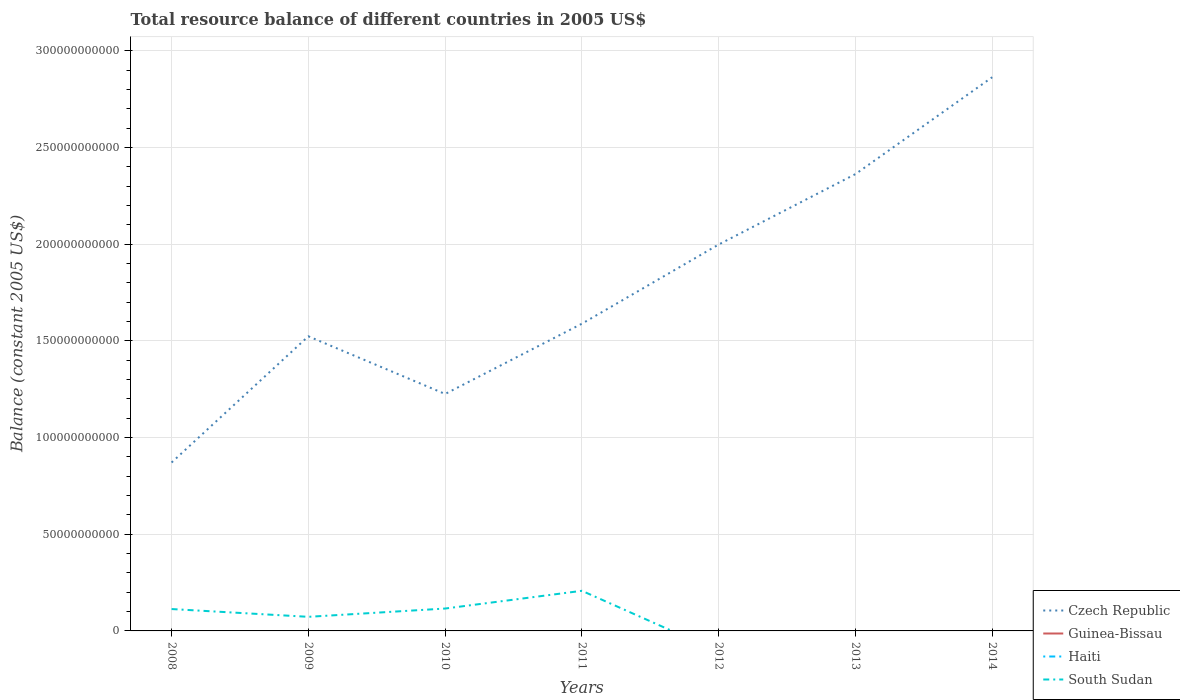How many different coloured lines are there?
Offer a terse response. 2. Across all years, what is the maximum total resource balance in Guinea-Bissau?
Your response must be concise. 0. What is the total total resource balance in South Sudan in the graph?
Give a very brief answer. -9.17e+09. What is the difference between the highest and the second highest total resource balance in South Sudan?
Your answer should be very brief. 2.07e+1. Is the total resource balance in Czech Republic strictly greater than the total resource balance in Guinea-Bissau over the years?
Ensure brevity in your answer.  No. How many lines are there?
Your response must be concise. 2. How many years are there in the graph?
Provide a short and direct response. 7. Are the values on the major ticks of Y-axis written in scientific E-notation?
Offer a very short reply. No. Does the graph contain any zero values?
Provide a short and direct response. Yes. Does the graph contain grids?
Your response must be concise. Yes. Where does the legend appear in the graph?
Your response must be concise. Bottom right. How many legend labels are there?
Offer a terse response. 4. How are the legend labels stacked?
Make the answer very short. Vertical. What is the title of the graph?
Offer a terse response. Total resource balance of different countries in 2005 US$. Does "Serbia" appear as one of the legend labels in the graph?
Your answer should be very brief. No. What is the label or title of the Y-axis?
Your response must be concise. Balance (constant 2005 US$). What is the Balance (constant 2005 US$) in Czech Republic in 2008?
Provide a succinct answer. 8.71e+1. What is the Balance (constant 2005 US$) in Haiti in 2008?
Keep it short and to the point. 0. What is the Balance (constant 2005 US$) of South Sudan in 2008?
Give a very brief answer. 1.13e+1. What is the Balance (constant 2005 US$) in Czech Republic in 2009?
Your answer should be very brief. 1.52e+11. What is the Balance (constant 2005 US$) of South Sudan in 2009?
Ensure brevity in your answer.  7.29e+09. What is the Balance (constant 2005 US$) of Czech Republic in 2010?
Your answer should be very brief. 1.23e+11. What is the Balance (constant 2005 US$) of South Sudan in 2010?
Make the answer very short. 1.16e+1. What is the Balance (constant 2005 US$) in Czech Republic in 2011?
Give a very brief answer. 1.59e+11. What is the Balance (constant 2005 US$) in Guinea-Bissau in 2011?
Provide a succinct answer. 0. What is the Balance (constant 2005 US$) in Haiti in 2011?
Give a very brief answer. 0. What is the Balance (constant 2005 US$) in South Sudan in 2011?
Keep it short and to the point. 2.07e+1. What is the Balance (constant 2005 US$) in Czech Republic in 2012?
Make the answer very short. 2.00e+11. What is the Balance (constant 2005 US$) in Guinea-Bissau in 2012?
Provide a short and direct response. 0. What is the Balance (constant 2005 US$) of South Sudan in 2012?
Your answer should be compact. 0. What is the Balance (constant 2005 US$) in Czech Republic in 2013?
Offer a very short reply. 2.36e+11. What is the Balance (constant 2005 US$) of Guinea-Bissau in 2013?
Provide a succinct answer. 0. What is the Balance (constant 2005 US$) in Haiti in 2013?
Your response must be concise. 0. What is the Balance (constant 2005 US$) in South Sudan in 2013?
Offer a very short reply. 0. What is the Balance (constant 2005 US$) in Czech Republic in 2014?
Your answer should be very brief. 2.86e+11. What is the Balance (constant 2005 US$) of Guinea-Bissau in 2014?
Give a very brief answer. 0. What is the Balance (constant 2005 US$) of Haiti in 2014?
Provide a succinct answer. 0. What is the Balance (constant 2005 US$) of South Sudan in 2014?
Make the answer very short. 0. Across all years, what is the maximum Balance (constant 2005 US$) in Czech Republic?
Your answer should be very brief. 2.86e+11. Across all years, what is the maximum Balance (constant 2005 US$) of South Sudan?
Provide a short and direct response. 2.07e+1. Across all years, what is the minimum Balance (constant 2005 US$) of Czech Republic?
Provide a short and direct response. 8.71e+1. Across all years, what is the minimum Balance (constant 2005 US$) of South Sudan?
Offer a terse response. 0. What is the total Balance (constant 2005 US$) in Czech Republic in the graph?
Provide a short and direct response. 1.24e+12. What is the total Balance (constant 2005 US$) of Haiti in the graph?
Your response must be concise. 0. What is the total Balance (constant 2005 US$) in South Sudan in the graph?
Offer a very short reply. 5.09e+1. What is the difference between the Balance (constant 2005 US$) of Czech Republic in 2008 and that in 2009?
Give a very brief answer. -6.53e+1. What is the difference between the Balance (constant 2005 US$) of South Sudan in 2008 and that in 2009?
Offer a terse response. 4.03e+09. What is the difference between the Balance (constant 2005 US$) in Czech Republic in 2008 and that in 2010?
Your response must be concise. -3.54e+1. What is the difference between the Balance (constant 2005 US$) of South Sudan in 2008 and that in 2010?
Provide a succinct answer. -2.60e+08. What is the difference between the Balance (constant 2005 US$) of Czech Republic in 2008 and that in 2011?
Your answer should be compact. -7.18e+1. What is the difference between the Balance (constant 2005 US$) in South Sudan in 2008 and that in 2011?
Offer a terse response. -9.43e+09. What is the difference between the Balance (constant 2005 US$) in Czech Republic in 2008 and that in 2012?
Your answer should be very brief. -1.13e+11. What is the difference between the Balance (constant 2005 US$) in Czech Republic in 2008 and that in 2013?
Offer a very short reply. -1.49e+11. What is the difference between the Balance (constant 2005 US$) in Czech Republic in 2008 and that in 2014?
Provide a short and direct response. -1.99e+11. What is the difference between the Balance (constant 2005 US$) of Czech Republic in 2009 and that in 2010?
Your answer should be compact. 2.98e+1. What is the difference between the Balance (constant 2005 US$) in South Sudan in 2009 and that in 2010?
Offer a very short reply. -4.29e+09. What is the difference between the Balance (constant 2005 US$) of Czech Republic in 2009 and that in 2011?
Keep it short and to the point. -6.51e+09. What is the difference between the Balance (constant 2005 US$) in South Sudan in 2009 and that in 2011?
Give a very brief answer. -1.35e+1. What is the difference between the Balance (constant 2005 US$) in Czech Republic in 2009 and that in 2012?
Your answer should be compact. -4.75e+1. What is the difference between the Balance (constant 2005 US$) of Czech Republic in 2009 and that in 2013?
Keep it short and to the point. -8.39e+1. What is the difference between the Balance (constant 2005 US$) of Czech Republic in 2009 and that in 2014?
Ensure brevity in your answer.  -1.34e+11. What is the difference between the Balance (constant 2005 US$) in Czech Republic in 2010 and that in 2011?
Offer a very short reply. -3.63e+1. What is the difference between the Balance (constant 2005 US$) in South Sudan in 2010 and that in 2011?
Offer a very short reply. -9.17e+09. What is the difference between the Balance (constant 2005 US$) in Czech Republic in 2010 and that in 2012?
Give a very brief answer. -7.73e+1. What is the difference between the Balance (constant 2005 US$) in Czech Republic in 2010 and that in 2013?
Your response must be concise. -1.14e+11. What is the difference between the Balance (constant 2005 US$) in Czech Republic in 2010 and that in 2014?
Give a very brief answer. -1.64e+11. What is the difference between the Balance (constant 2005 US$) of Czech Republic in 2011 and that in 2012?
Your response must be concise. -4.09e+1. What is the difference between the Balance (constant 2005 US$) of Czech Republic in 2011 and that in 2013?
Give a very brief answer. -7.74e+1. What is the difference between the Balance (constant 2005 US$) in Czech Republic in 2011 and that in 2014?
Keep it short and to the point. -1.27e+11. What is the difference between the Balance (constant 2005 US$) in Czech Republic in 2012 and that in 2013?
Your answer should be very brief. -3.64e+1. What is the difference between the Balance (constant 2005 US$) in Czech Republic in 2012 and that in 2014?
Ensure brevity in your answer.  -8.65e+1. What is the difference between the Balance (constant 2005 US$) in Czech Republic in 2013 and that in 2014?
Provide a short and direct response. -5.01e+1. What is the difference between the Balance (constant 2005 US$) of Czech Republic in 2008 and the Balance (constant 2005 US$) of South Sudan in 2009?
Make the answer very short. 7.98e+1. What is the difference between the Balance (constant 2005 US$) of Czech Republic in 2008 and the Balance (constant 2005 US$) of South Sudan in 2010?
Provide a short and direct response. 7.55e+1. What is the difference between the Balance (constant 2005 US$) in Czech Republic in 2008 and the Balance (constant 2005 US$) in South Sudan in 2011?
Make the answer very short. 6.63e+1. What is the difference between the Balance (constant 2005 US$) of Czech Republic in 2009 and the Balance (constant 2005 US$) of South Sudan in 2010?
Your response must be concise. 1.41e+11. What is the difference between the Balance (constant 2005 US$) of Czech Republic in 2009 and the Balance (constant 2005 US$) of South Sudan in 2011?
Provide a succinct answer. 1.32e+11. What is the difference between the Balance (constant 2005 US$) in Czech Republic in 2010 and the Balance (constant 2005 US$) in South Sudan in 2011?
Ensure brevity in your answer.  1.02e+11. What is the average Balance (constant 2005 US$) of Czech Republic per year?
Make the answer very short. 1.78e+11. What is the average Balance (constant 2005 US$) of Guinea-Bissau per year?
Your response must be concise. 0. What is the average Balance (constant 2005 US$) in Haiti per year?
Make the answer very short. 0. What is the average Balance (constant 2005 US$) of South Sudan per year?
Keep it short and to the point. 7.27e+09. In the year 2008, what is the difference between the Balance (constant 2005 US$) in Czech Republic and Balance (constant 2005 US$) in South Sudan?
Offer a very short reply. 7.58e+1. In the year 2009, what is the difference between the Balance (constant 2005 US$) of Czech Republic and Balance (constant 2005 US$) of South Sudan?
Your answer should be compact. 1.45e+11. In the year 2010, what is the difference between the Balance (constant 2005 US$) of Czech Republic and Balance (constant 2005 US$) of South Sudan?
Keep it short and to the point. 1.11e+11. In the year 2011, what is the difference between the Balance (constant 2005 US$) in Czech Republic and Balance (constant 2005 US$) in South Sudan?
Your answer should be very brief. 1.38e+11. What is the ratio of the Balance (constant 2005 US$) in Czech Republic in 2008 to that in 2009?
Give a very brief answer. 0.57. What is the ratio of the Balance (constant 2005 US$) of South Sudan in 2008 to that in 2009?
Give a very brief answer. 1.55. What is the ratio of the Balance (constant 2005 US$) in Czech Republic in 2008 to that in 2010?
Give a very brief answer. 0.71. What is the ratio of the Balance (constant 2005 US$) in South Sudan in 2008 to that in 2010?
Provide a short and direct response. 0.98. What is the ratio of the Balance (constant 2005 US$) of Czech Republic in 2008 to that in 2011?
Provide a short and direct response. 0.55. What is the ratio of the Balance (constant 2005 US$) in South Sudan in 2008 to that in 2011?
Your response must be concise. 0.55. What is the ratio of the Balance (constant 2005 US$) in Czech Republic in 2008 to that in 2012?
Ensure brevity in your answer.  0.44. What is the ratio of the Balance (constant 2005 US$) of Czech Republic in 2008 to that in 2013?
Give a very brief answer. 0.37. What is the ratio of the Balance (constant 2005 US$) in Czech Republic in 2008 to that in 2014?
Provide a succinct answer. 0.3. What is the ratio of the Balance (constant 2005 US$) in Czech Republic in 2009 to that in 2010?
Provide a succinct answer. 1.24. What is the ratio of the Balance (constant 2005 US$) of South Sudan in 2009 to that in 2010?
Keep it short and to the point. 0.63. What is the ratio of the Balance (constant 2005 US$) of South Sudan in 2009 to that in 2011?
Offer a terse response. 0.35. What is the ratio of the Balance (constant 2005 US$) of Czech Republic in 2009 to that in 2012?
Offer a very short reply. 0.76. What is the ratio of the Balance (constant 2005 US$) in Czech Republic in 2009 to that in 2013?
Provide a succinct answer. 0.64. What is the ratio of the Balance (constant 2005 US$) in Czech Republic in 2009 to that in 2014?
Ensure brevity in your answer.  0.53. What is the ratio of the Balance (constant 2005 US$) in Czech Republic in 2010 to that in 2011?
Give a very brief answer. 0.77. What is the ratio of the Balance (constant 2005 US$) of South Sudan in 2010 to that in 2011?
Keep it short and to the point. 0.56. What is the ratio of the Balance (constant 2005 US$) of Czech Republic in 2010 to that in 2012?
Offer a very short reply. 0.61. What is the ratio of the Balance (constant 2005 US$) in Czech Republic in 2010 to that in 2013?
Provide a succinct answer. 0.52. What is the ratio of the Balance (constant 2005 US$) of Czech Republic in 2010 to that in 2014?
Offer a very short reply. 0.43. What is the ratio of the Balance (constant 2005 US$) in Czech Republic in 2011 to that in 2012?
Your response must be concise. 0.8. What is the ratio of the Balance (constant 2005 US$) of Czech Republic in 2011 to that in 2013?
Your answer should be very brief. 0.67. What is the ratio of the Balance (constant 2005 US$) of Czech Republic in 2011 to that in 2014?
Ensure brevity in your answer.  0.55. What is the ratio of the Balance (constant 2005 US$) in Czech Republic in 2012 to that in 2013?
Offer a terse response. 0.85. What is the ratio of the Balance (constant 2005 US$) in Czech Republic in 2012 to that in 2014?
Give a very brief answer. 0.7. What is the ratio of the Balance (constant 2005 US$) in Czech Republic in 2013 to that in 2014?
Your response must be concise. 0.82. What is the difference between the highest and the second highest Balance (constant 2005 US$) of Czech Republic?
Make the answer very short. 5.01e+1. What is the difference between the highest and the second highest Balance (constant 2005 US$) of South Sudan?
Offer a very short reply. 9.17e+09. What is the difference between the highest and the lowest Balance (constant 2005 US$) in Czech Republic?
Offer a terse response. 1.99e+11. What is the difference between the highest and the lowest Balance (constant 2005 US$) of South Sudan?
Offer a very short reply. 2.07e+1. 